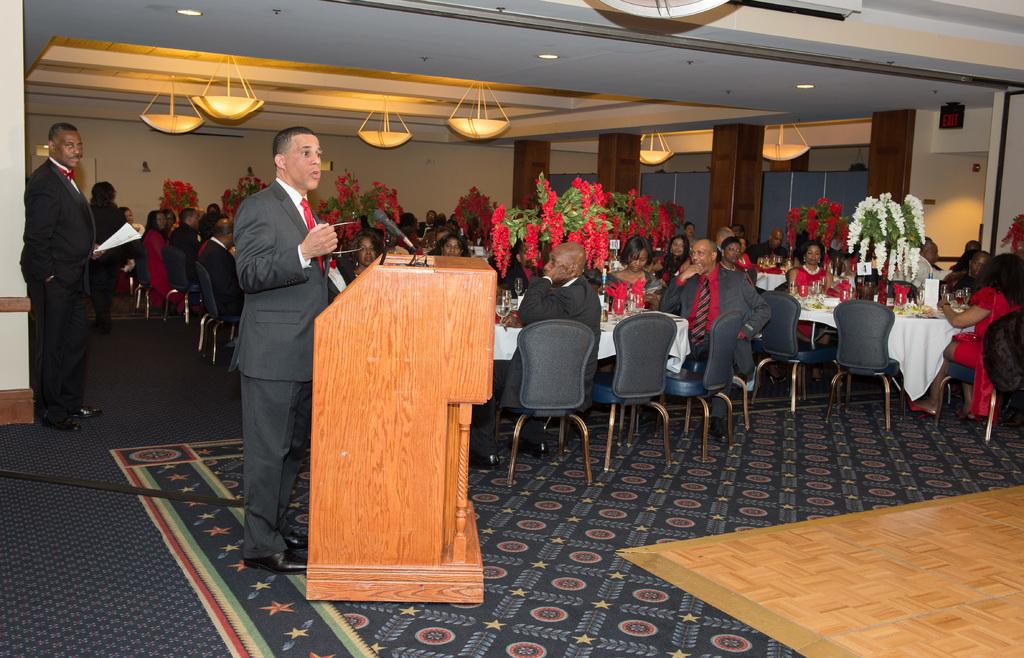What is the main subject of the image? There is a person standing in the middle of the image. What is the person doing in the image? The person is speaking into a microphone. What can be seen on the right side of the image? There are people sitting on chairs in the right side of the image. How are the chairs arranged in the image? The chairs are arranged around a dining table. What is visible on the roof in the image? There are lights visible on the roof. What type of locket is the person wearing in the image? There is no locket visible on the person in the image. How does the person use self-control while speaking into the microphone? The image does not provide information about the person's self-control or emotions while speaking into the microphone. 